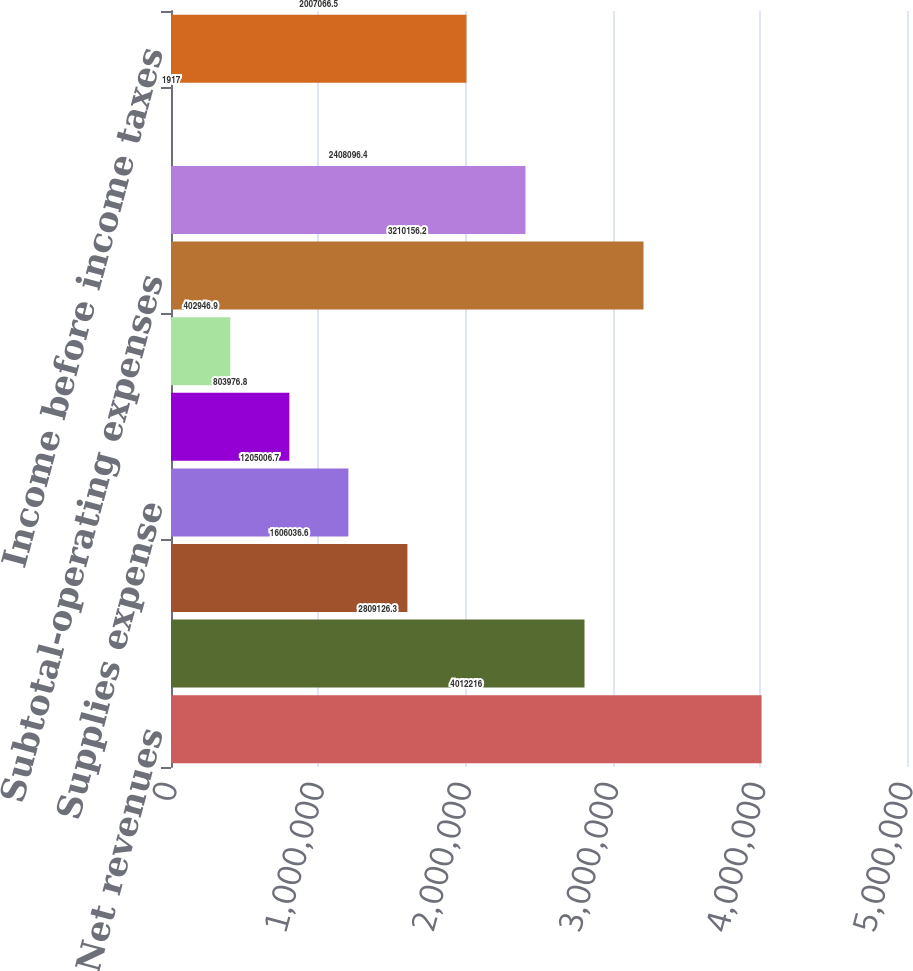<chart> <loc_0><loc_0><loc_500><loc_500><bar_chart><fcel>Net revenues<fcel>Salaries wages and benefits<fcel>Other operating expenses<fcel>Supplies expense<fcel>Depreciation and amortization<fcel>Lease and rental expense<fcel>Subtotal-operating expenses<fcel>Income from operations<fcel>Interest expense net<fcel>Income before income taxes<nl><fcel>4.01222e+06<fcel>2.80913e+06<fcel>1.60604e+06<fcel>1.20501e+06<fcel>803977<fcel>402947<fcel>3.21016e+06<fcel>2.4081e+06<fcel>1917<fcel>2.00707e+06<nl></chart> 